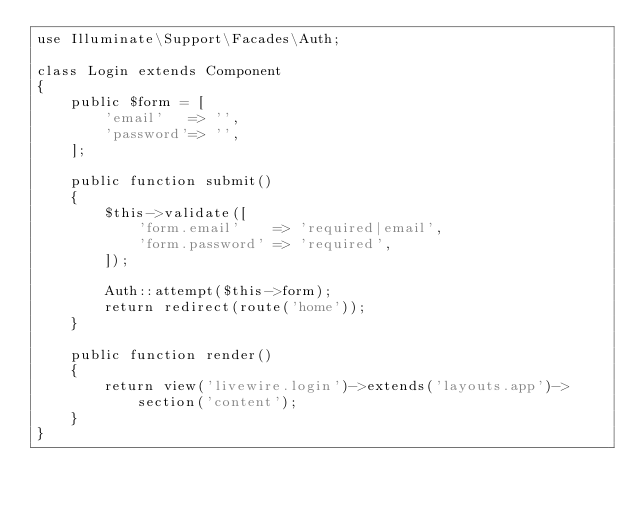Convert code to text. <code><loc_0><loc_0><loc_500><loc_500><_PHP_>use Illuminate\Support\Facades\Auth;

class Login extends Component
{
    public $form = [
        'email'   => '',
        'password'=> '',
    ];

    public function submit()
    {
        $this->validate([
            'form.email'    => 'required|email',
            'form.password' => 'required',
        ]);

        Auth::attempt($this->form);
        return redirect(route('home'));
    }

    public function render()
    {
        return view('livewire.login')->extends('layouts.app')->section('content');
    }
}
</code> 